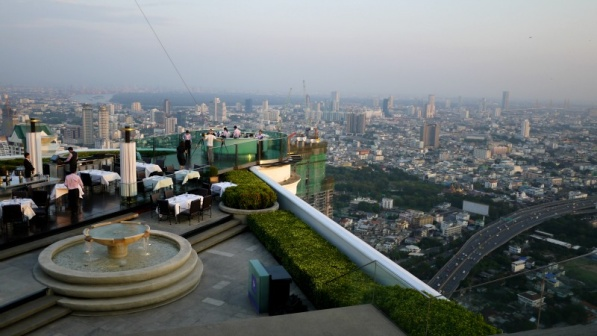Describe the ambiance during a sunset at this rooftop bar. During sunset, the ambiance at this rooftop bar transforms into a magical and romantic setting. The sky is painted in hues of orange, pink, and purple, casting a warm and enchanting glow over the entire area. The city below begins to twinkle as lights start turning on, creating a mesmerizing contrast with the colorful sky. Patrons are likely to be relaxed, enjoying their drinks while soaking in the stunning views and the calming atmosphere. The gentle breeze and the soothing sounds of the fountain add to the ambiance, making it a perfect place to unwind and appreciate the beauty of the transition from day to night. What might a typical evening look like at this bar during a weekend? On a typical weekend evening, the rooftop bar is bustling with energy and excitement. Groups of friends and couples gather to enjoy the scenic views, delicious cocktails, and delectable food. The tables are filled with lively conversations and laughter, creating a vibrant and sociable atmosphere. As the evening progresses, soft background music intensifies, perhaps with a live DJ or a band performing, adding to the dynamic ambiance. The fountain continues to provide a calming effect, balancing the lively surroundings. The city below, illuminated with countless lights, enhances the overall experience, making it a memorable night for all attendees. Imagine if this rooftop bar were in a fantastical world. What unique elements might it have? In a fantastical world, this rooftop bar could feature extraordinary elements that spark the imagination. Picture crystal-clear glass flooring, allowing patrons to look directly down at the vibrant city far below, giving the sensation of floating in mid-air. Exotic, bioluminescent plants could line the perimeters, glowing softly in various colors to complement the sunset hues. Instead of traditional umbrellas, shimmering force fields could provide elegant, transparent shades that adjust with the sun's movement. The fountain might be enchanted, with sparkling water that dances to the rhythm of the music playing in the background. Additionally, friendly mythical creatures such as miniature dragons or luminous fairies might flit around, adding an extra layer of magic to the already enchanting setting. 